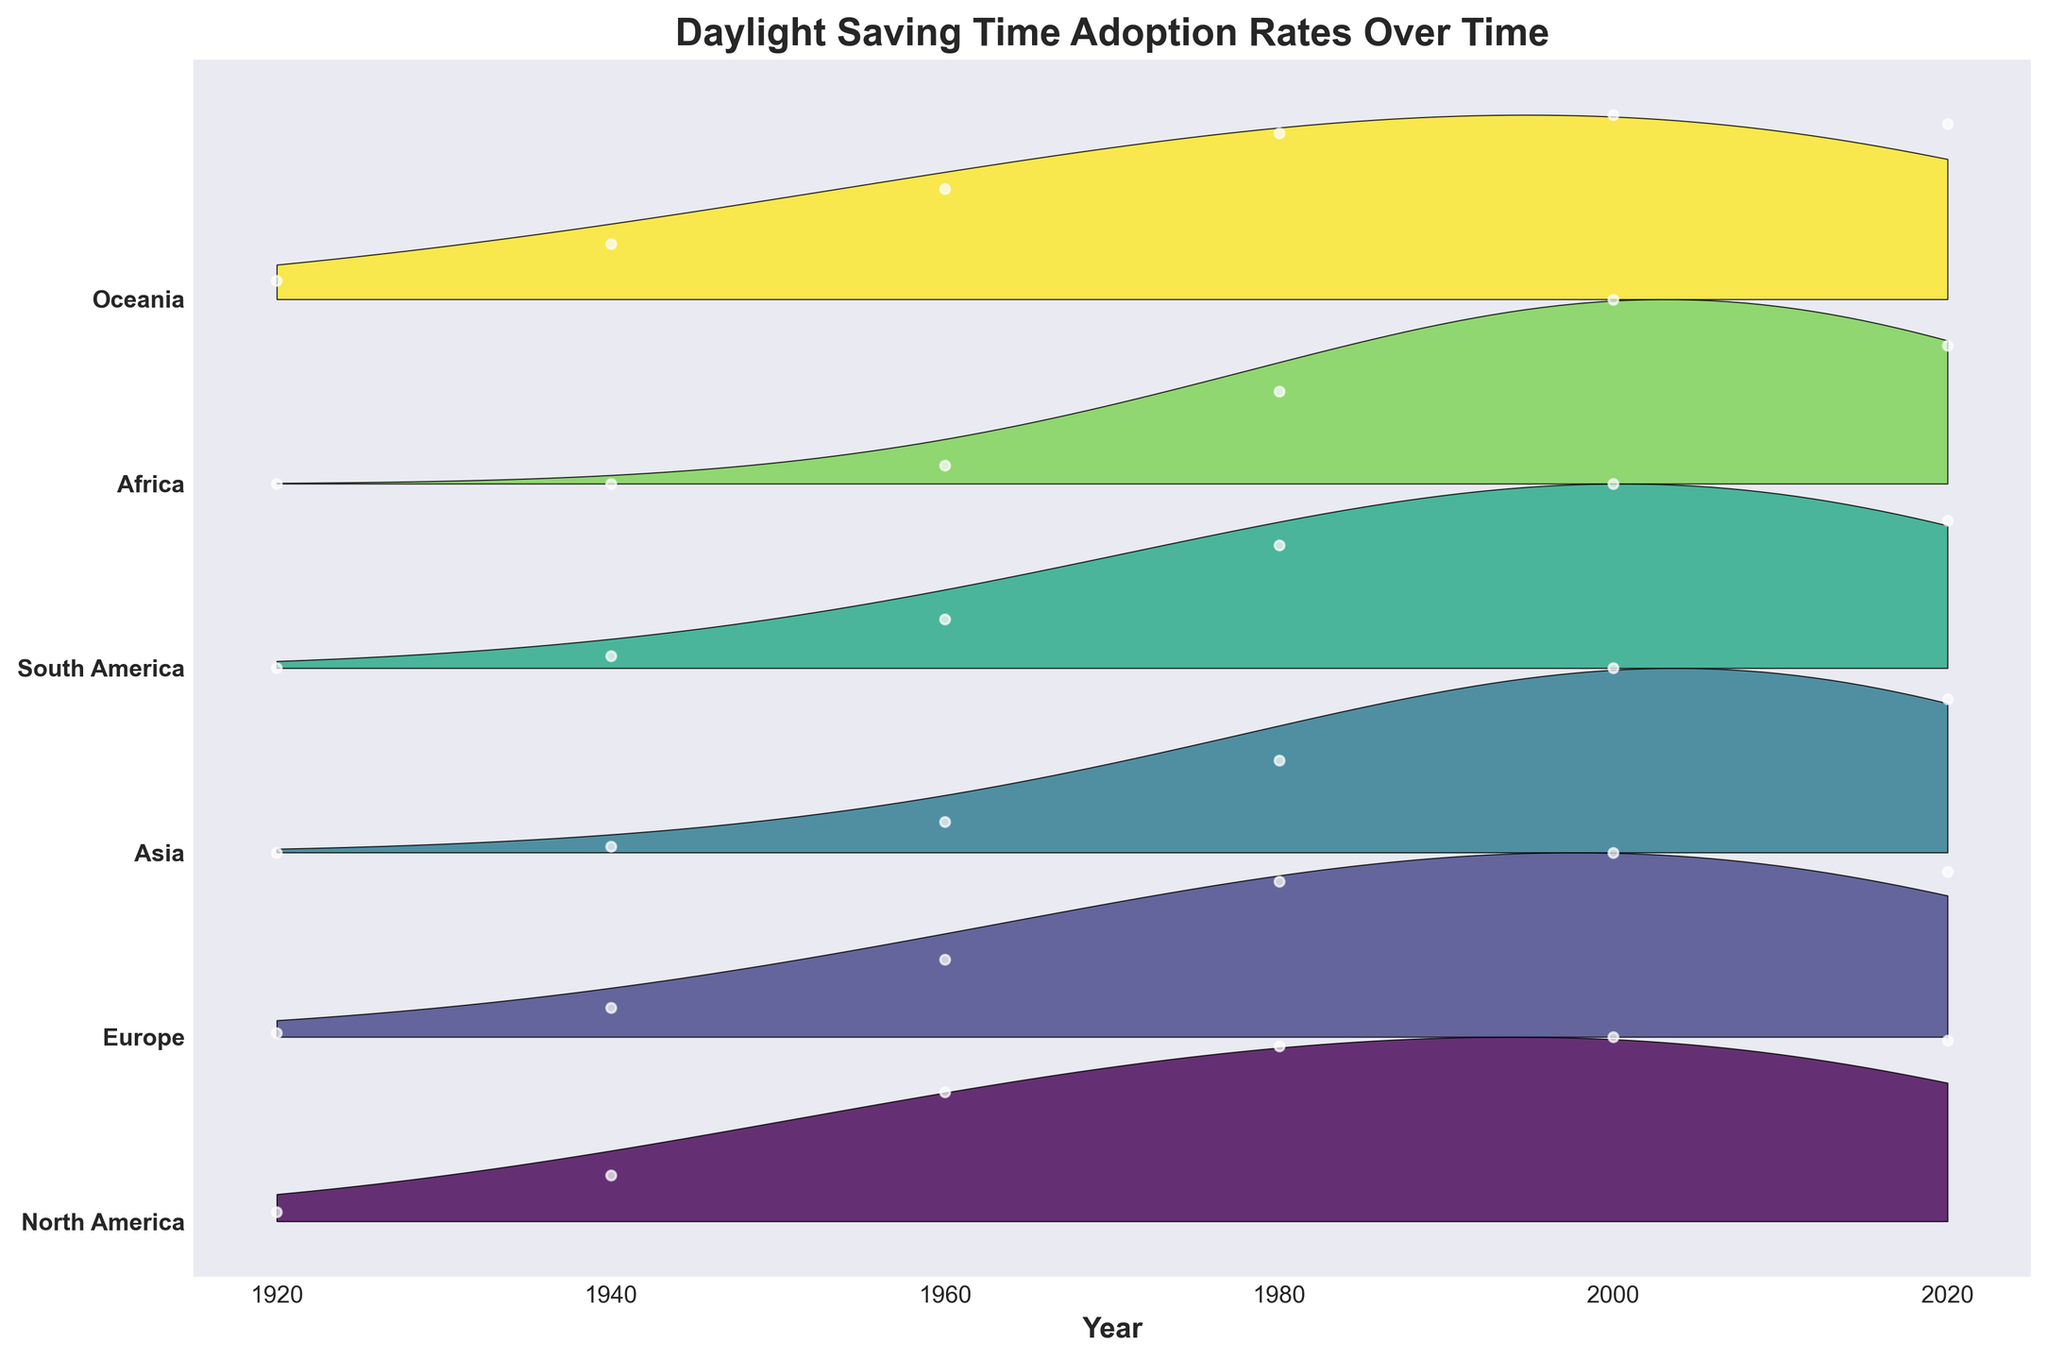What is the title of the figure? The title of the figure is displayed at the top of the plot. It's clearly written in large, bold text.
Answer: Daylight Saving Time Adoption Rates Over Time How many major world regions are shown in the plot? The y-axis labels the regions, and you can count them to find the total number of regions.
Answer: 6 Which region has the highest adoption rate in the year 2000? Look for the highest point in the plot corresponding to the year 2000 and note which region it is associated with.
Answer: North America and Oceania Which region shows a decline in adoption rate from 2000 to 2020? Identify the regions with a higher adoption rate in 2000 than in 2020 by observing the plotted lines.
Answer: Europe and South America In which year did North America reach a 50% adoption rate? Locate the point where North America's adoption rate plot crosses the 0.50 mark and read the corresponding year.
Answer: Around 1960 Which two regions had no adoption of daylight saving time in 1920? Identify the regions whose plotted lines are at 0 in the year 1920.
Answer: Asia and South America What is the average adoption rate for Europe between 1920 and 2020? Sum the adoption rates for Europe for all the years provided, then divide by the number of years (6).
Answer: (0.02 + 0.15 + 0.40 + 0.80 + 0.95 + 0.85) / 6 = 0.529 or approximately 0.53 Which region shows the slowest growth in adoption rate over the century? Compare the slopes of the plotted lines from 1920 to 2020 for each region to determine the one with the slowest increase.
Answer: Africa In which year did Oceania reach a 90% adoption rate? Find the point where Oceania's plotted line crosses the 0.90 mark and identify the corresponding year.
Answer: Around 1980 